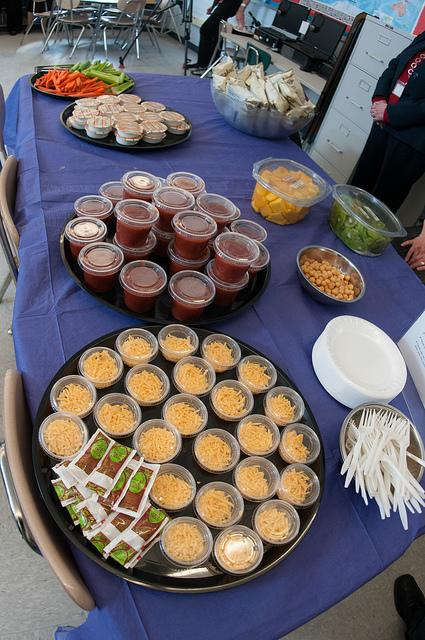What type of building might this be?

Choices:
A) daycare
B) school
C) courthouse
D) church school 